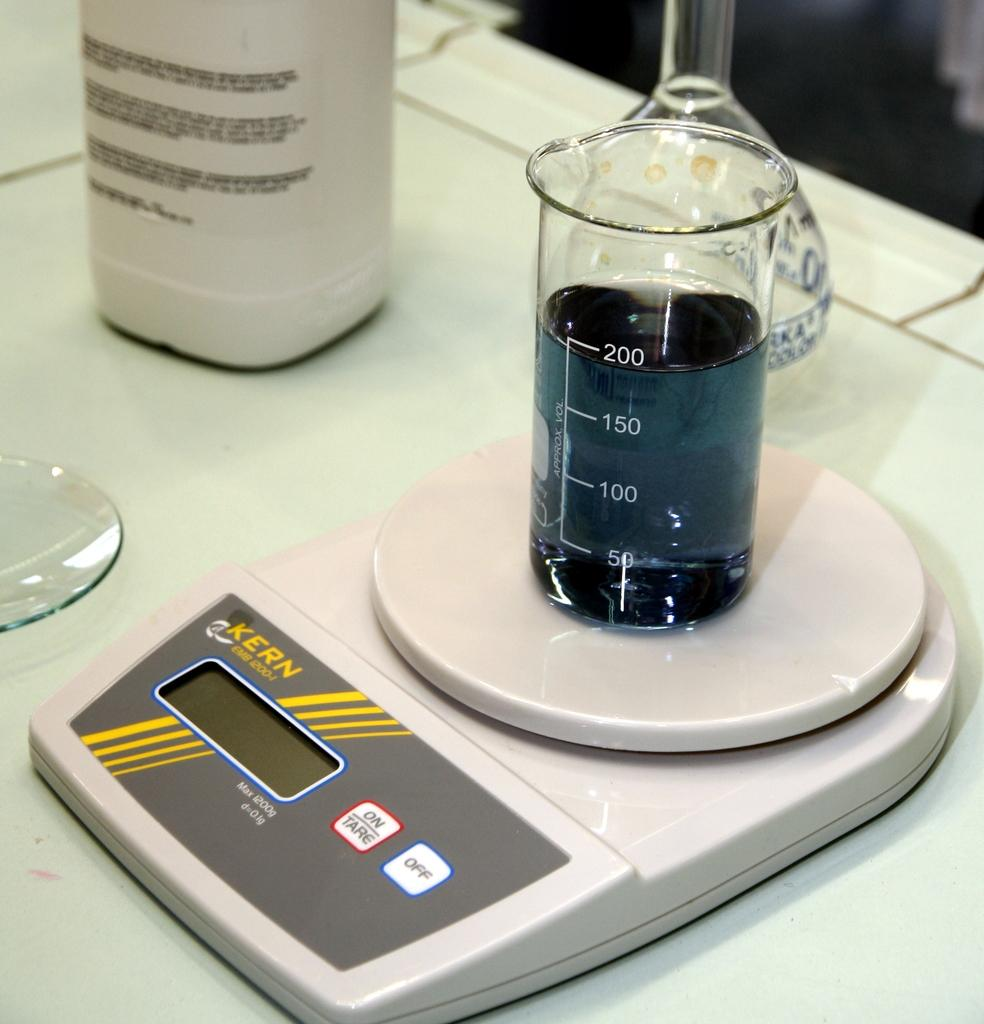Provide a one-sentence caption for the provided image. a Kern scale weighing a beaker of blue liquid filled to the 200 mark. 